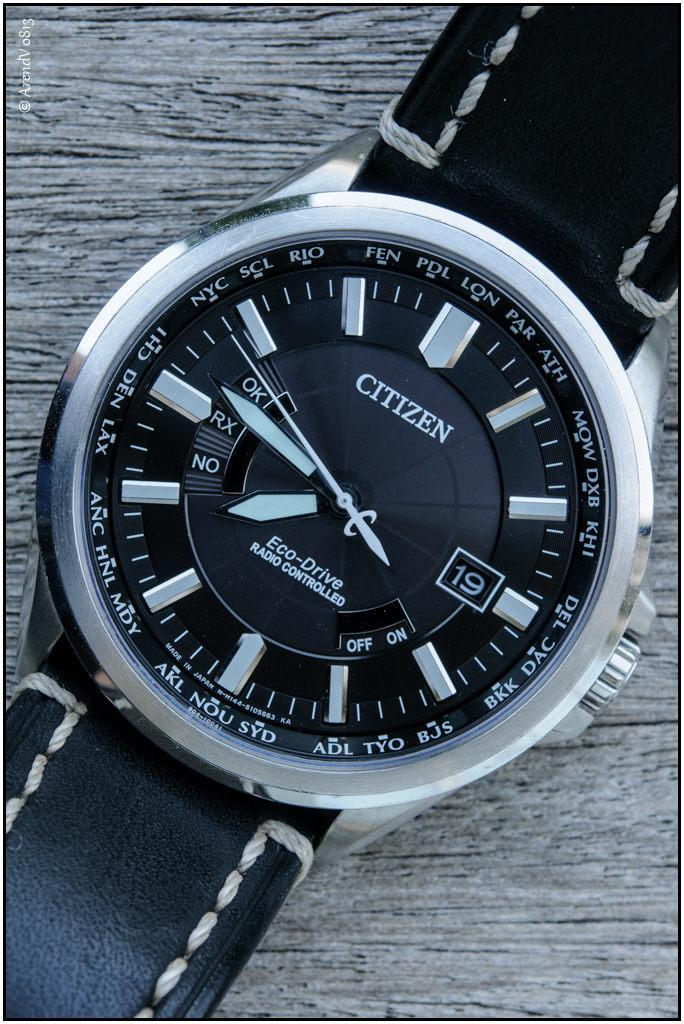<image>
Present a compact description of the photo's key features. Black and silver writstwatch that says CITIZEN on the face. 